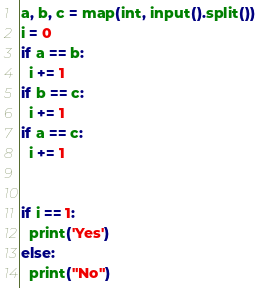<code> <loc_0><loc_0><loc_500><loc_500><_Python_>a, b, c = map(int, input().split())
i = 0
if a == b:
  i += 1
if b == c:
  i += 1
if a == c:
  i += 1
  
  
if i == 1: 
  print('Yes')
else:
  print("No")</code> 